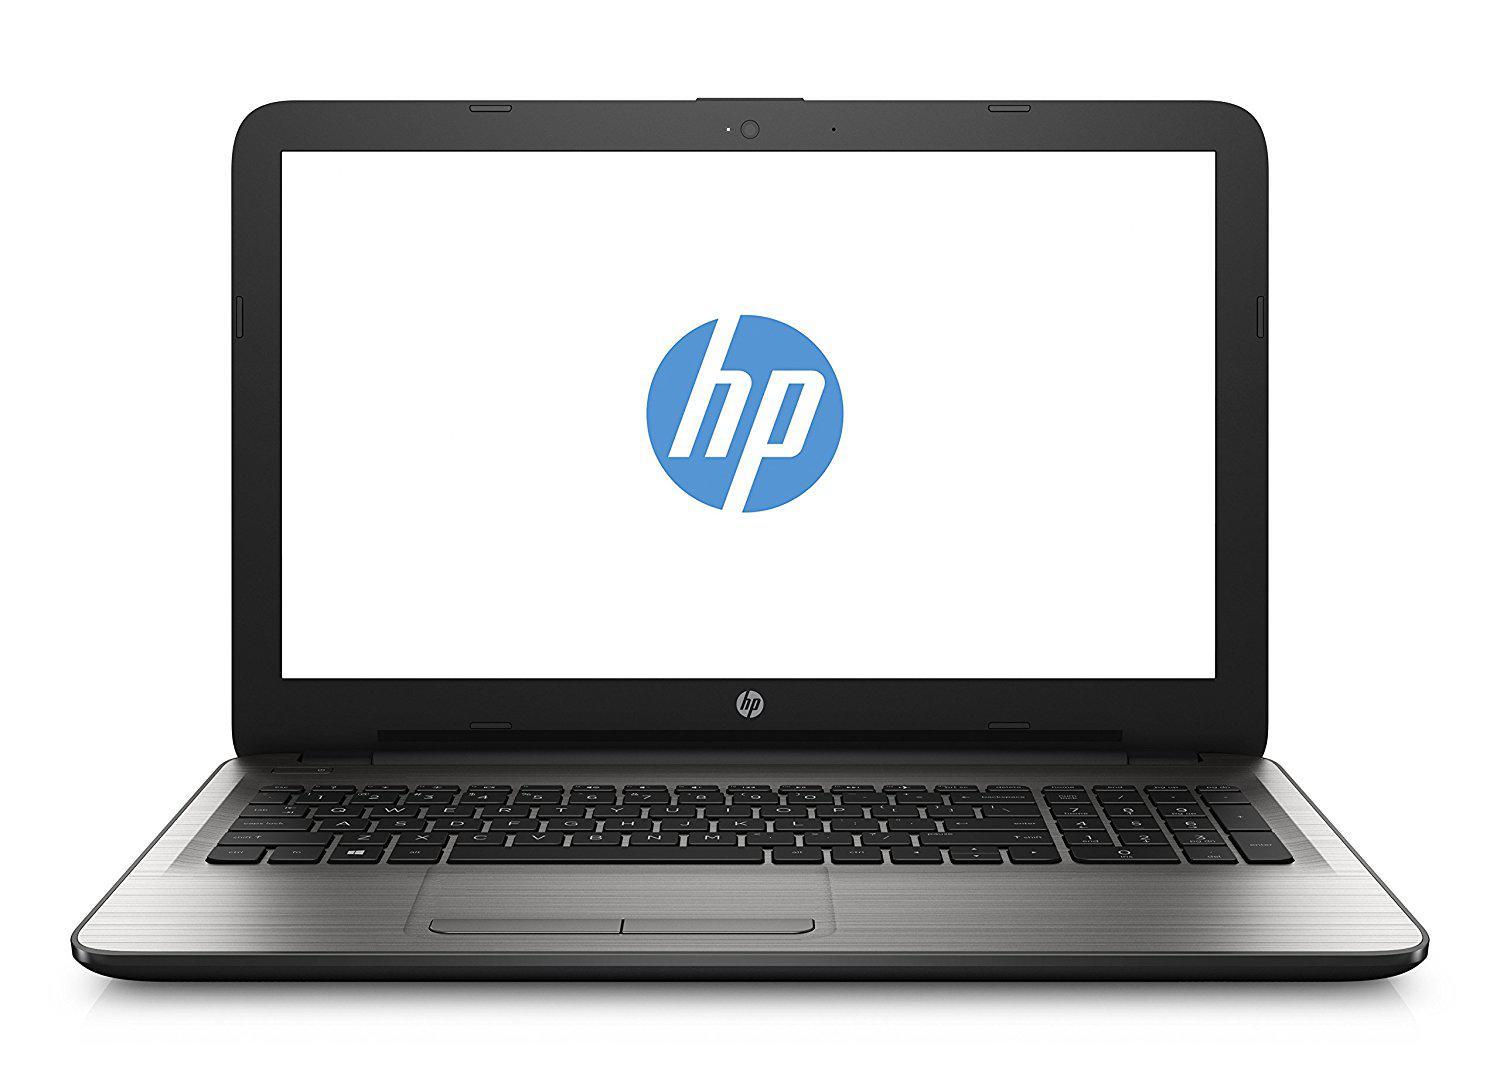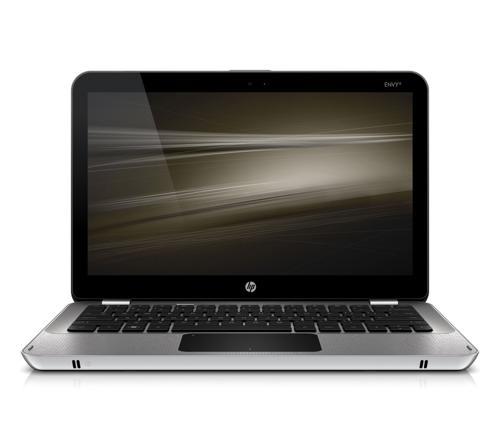The first image is the image on the left, the second image is the image on the right. Given the left and right images, does the statement "One open laptop is displayed head-on, and the other open laptop is displayed at an angle with its screen facing away from the camera toward the left." hold true? Answer yes or no. No. The first image is the image on the left, the second image is the image on the right. Considering the images on both sides, is "One laptop is facing directly forward, and another laptop is facing diagonally backward." valid? Answer yes or no. No. 